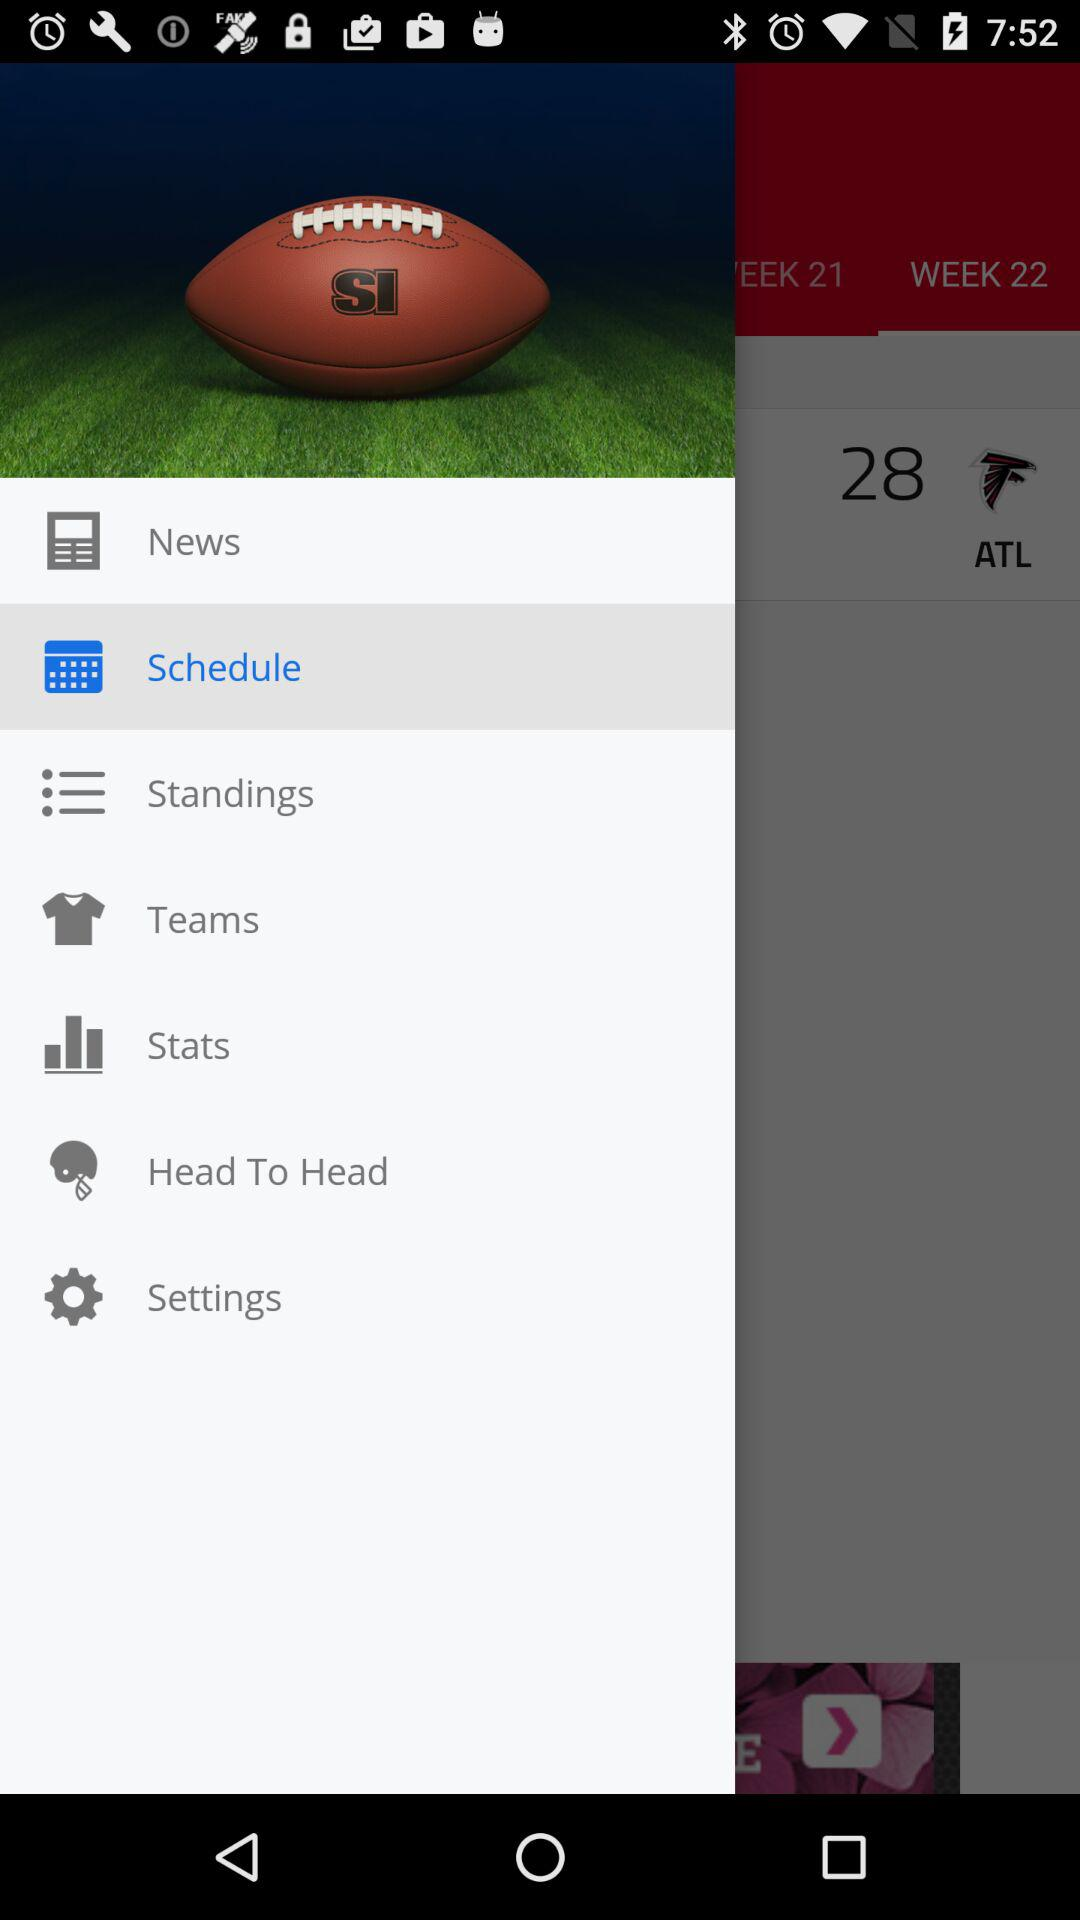Which tab is selected? The selected tab is "WEEK 22". 